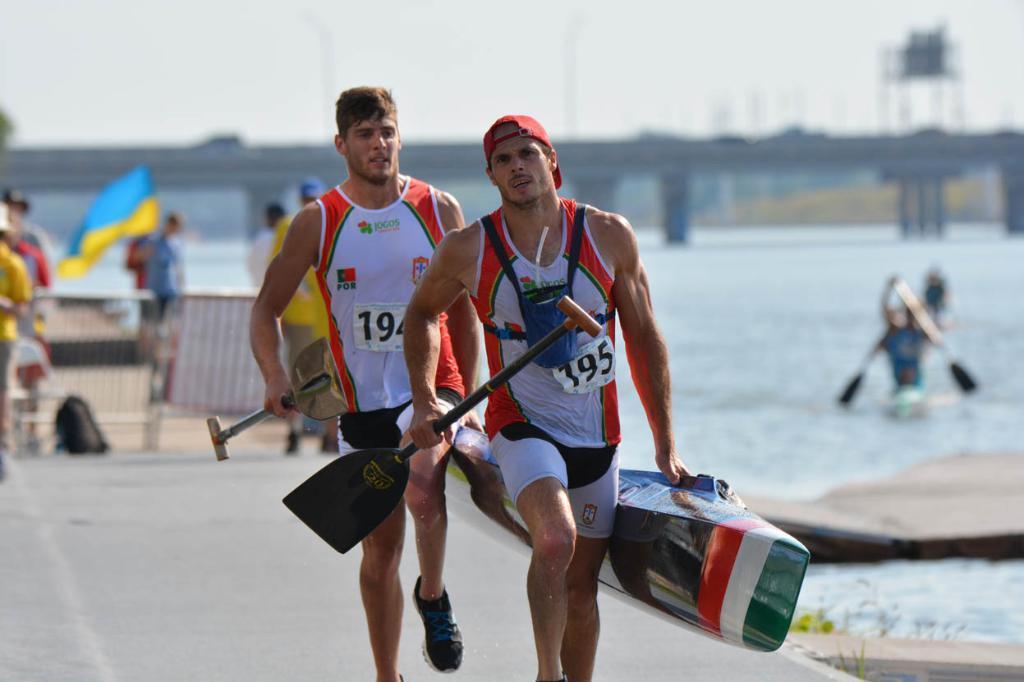Can you describe this image briefly? In this picture I can see people are riding on water with surf board and also we can see two persons are holding surf board and running on the road, behind we can see a blur image of few people, flags, we can see a bridge with some vehicles. 